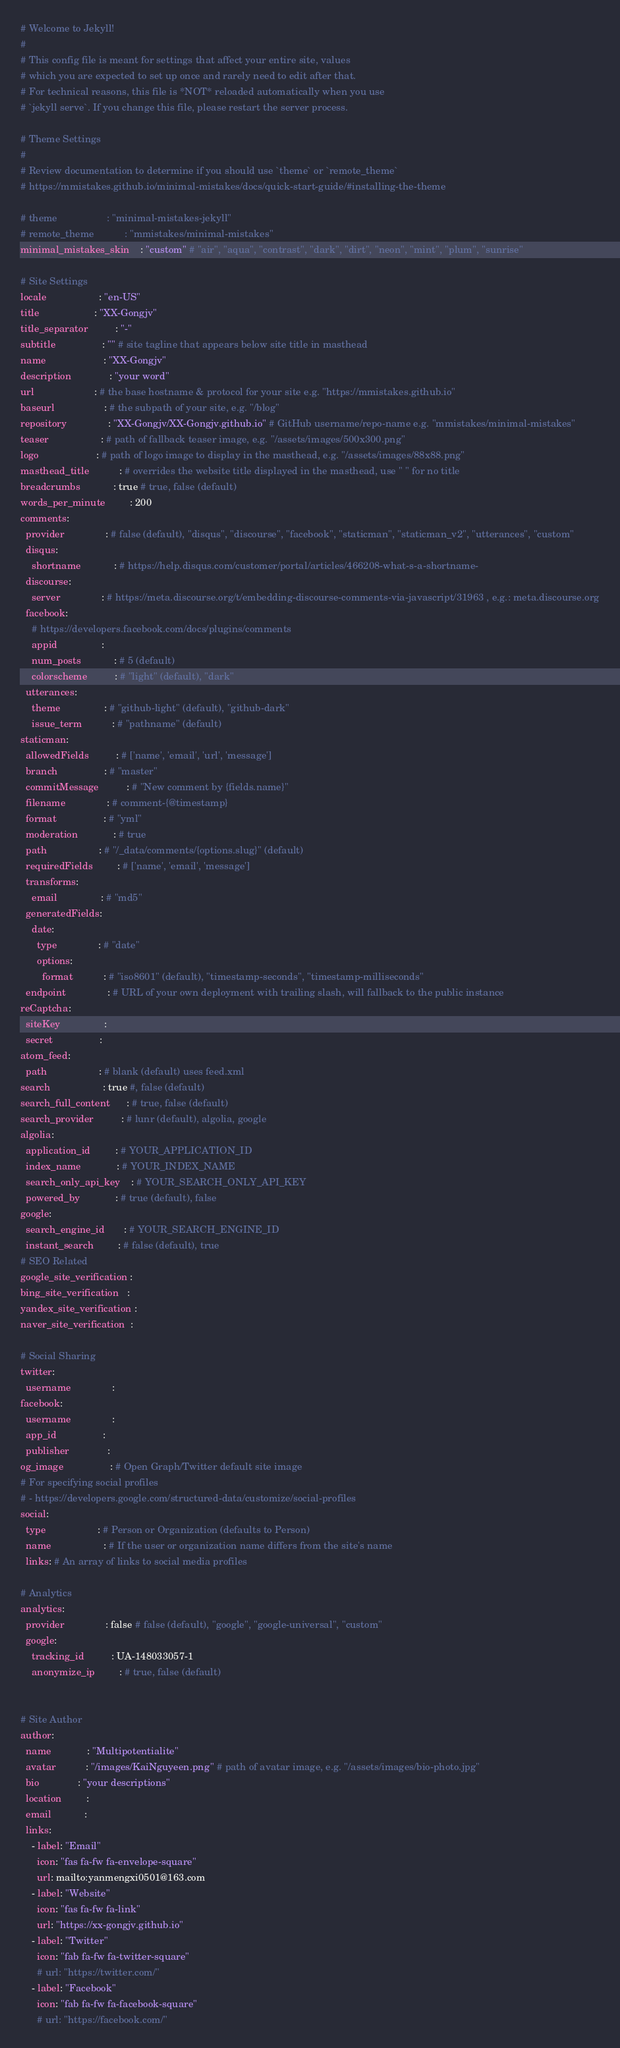Convert code to text. <code><loc_0><loc_0><loc_500><loc_500><_YAML_># Welcome to Jekyll!
#
# This config file is meant for settings that affect your entire site, values
# which you are expected to set up once and rarely need to edit after that.
# For technical reasons, this file is *NOT* reloaded automatically when you use
# `jekyll serve`. If you change this file, please restart the server process.

# Theme Settings
#
# Review documentation to determine if you should use `theme` or `remote_theme`
# https://mmistakes.github.io/minimal-mistakes/docs/quick-start-guide/#installing-the-theme

# theme                  : "minimal-mistakes-jekyll"
# remote_theme           : "mmistakes/minimal-mistakes"
minimal_mistakes_skin    : "custom" # "air", "aqua", "contrast", "dark", "dirt", "neon", "mint", "plum", "sunrise"

# Site Settings
locale                   : "en-US"
title                    : "XX-Gongjv"
title_separator          : "-"
subtitle                 : "" # site tagline that appears below site title in masthead
name                     : "XX-Gongjv"
description              : "your word"
url                      : # the base hostname & protocol for your site e.g. "https://mmistakes.github.io"
baseurl                  : # the subpath of your site, e.g. "/blog"
repository               : "XX-Gongjv/XX-Gongjv.github.io" # GitHub username/repo-name e.g. "mmistakes/minimal-mistakes"
teaser                   : # path of fallback teaser image, e.g. "/assets/images/500x300.png"
logo                     : # path of logo image to display in the masthead, e.g. "/assets/images/88x88.png"
masthead_title           : # overrides the website title displayed in the masthead, use " " for no title
breadcrumbs            : true # true, false (default)
words_per_minute         : 200
comments:
  provider               : # false (default), "disqus", "discourse", "facebook", "staticman", "staticman_v2", "utterances", "custom"
  disqus:
    shortname            : # https://help.disqus.com/customer/portal/articles/466208-what-s-a-shortname-
  discourse:
    server               : # https://meta.discourse.org/t/embedding-discourse-comments-via-javascript/31963 , e.g.: meta.discourse.org
  facebook:
    # https://developers.facebook.com/docs/plugins/comments
    appid                :
    num_posts            : # 5 (default)
    colorscheme          : # "light" (default), "dark"
  utterances:
    theme                : # "github-light" (default), "github-dark"
    issue_term           : # "pathname" (default)
staticman:
  allowedFields          : # ['name', 'email', 'url', 'message']
  branch                 : # "master"
  commitMessage          : # "New comment by {fields.name}"
  filename               : # comment-{@timestamp}
  format                 : # "yml"
  moderation             : # true
  path                   : # "/_data/comments/{options.slug}" (default)
  requiredFields         : # ['name', 'email', 'message']
  transforms:
    email                : # "md5"
  generatedFields:
    date:
      type               : # "date"
      options:
        format           : # "iso8601" (default), "timestamp-seconds", "timestamp-milliseconds"
  endpoint               : # URL of your own deployment with trailing slash, will fallback to the public instance
reCaptcha:
  siteKey                :
  secret                 :
atom_feed:
  path                   : # blank (default) uses feed.xml
search                   : true #, false (default)
search_full_content      : # true, false (default)
search_provider          : # lunr (default), algolia, google
algolia:
  application_id         : # YOUR_APPLICATION_ID
  index_name             : # YOUR_INDEX_NAME
  search_only_api_key    : # YOUR_SEARCH_ONLY_API_KEY
  powered_by             : # true (default), false
google:
  search_engine_id       : # YOUR_SEARCH_ENGINE_ID
  instant_search         : # false (default), true
# SEO Related
google_site_verification :
bing_site_verification   :
yandex_site_verification :
naver_site_verification  :

# Social Sharing
twitter:
  username               :
facebook:
  username               :
  app_id                 :
  publisher              :
og_image                 : # Open Graph/Twitter default site image
# For specifying social profiles
# - https://developers.google.com/structured-data/customize/social-profiles
social:
  type                   : # Person or Organization (defaults to Person)
  name                   : # If the user or organization name differs from the site's name
  links: # An array of links to social media profiles

# Analytics
analytics:
  provider               : false # false (default), "google", "google-universal", "custom"
  google:
    tracking_id          : UA-148033057-1
    anonymize_ip         : # true, false (default)


# Site Author
author:
  name             : "Multipotentialite"
  avatar           : "/images/KaiNguyeen.png" # path of avatar image, e.g. "/assets/images/bio-photo.jpg"
  bio              : "your descriptions"
  location         : 
  email            : 
  links:
    - label: "Email"
      icon: "fas fa-fw fa-envelope-square"
      url: mailto:yanmengxi0501@163.com
    - label: "Website"
      icon: "fas fa-fw fa-link"
      url: "https://xx-gongjv.github.io"
    - label: "Twitter"
      icon: "fab fa-fw fa-twitter-square"
      # url: "https://twitter.com/"
    - label: "Facebook"
      icon: "fab fa-fw fa-facebook-square"
      # url: "https://facebook.com/"</code> 